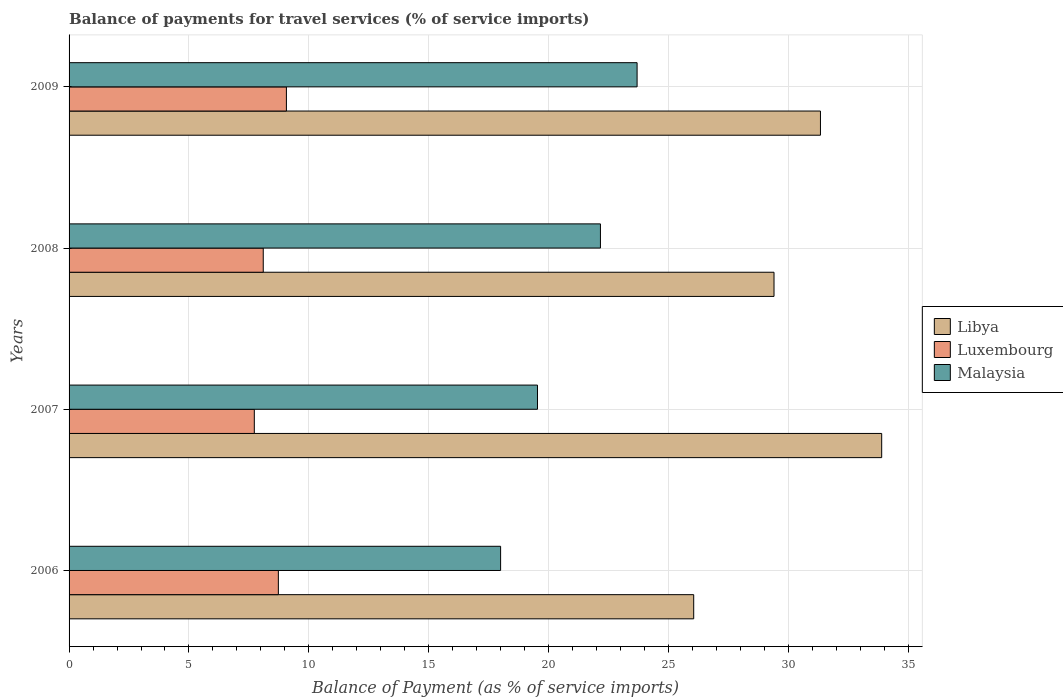How many different coloured bars are there?
Your answer should be compact. 3. How many groups of bars are there?
Your answer should be compact. 4. How many bars are there on the 3rd tick from the bottom?
Provide a short and direct response. 3. In how many cases, is the number of bars for a given year not equal to the number of legend labels?
Make the answer very short. 0. What is the balance of payments for travel services in Malaysia in 2008?
Offer a very short reply. 22.16. Across all years, what is the maximum balance of payments for travel services in Libya?
Your answer should be compact. 33.89. Across all years, what is the minimum balance of payments for travel services in Libya?
Offer a terse response. 26.05. In which year was the balance of payments for travel services in Malaysia minimum?
Provide a succinct answer. 2006. What is the total balance of payments for travel services in Luxembourg in the graph?
Provide a succinct answer. 33.62. What is the difference between the balance of payments for travel services in Libya in 2007 and that in 2008?
Provide a succinct answer. 4.49. What is the difference between the balance of payments for travel services in Luxembourg in 2006 and the balance of payments for travel services in Libya in 2007?
Provide a succinct answer. -25.16. What is the average balance of payments for travel services in Luxembourg per year?
Ensure brevity in your answer.  8.4. In the year 2006, what is the difference between the balance of payments for travel services in Libya and balance of payments for travel services in Luxembourg?
Ensure brevity in your answer.  17.32. In how many years, is the balance of payments for travel services in Libya greater than 14 %?
Your answer should be compact. 4. What is the ratio of the balance of payments for travel services in Malaysia in 2006 to that in 2007?
Ensure brevity in your answer.  0.92. Is the balance of payments for travel services in Luxembourg in 2007 less than that in 2009?
Make the answer very short. Yes. Is the difference between the balance of payments for travel services in Libya in 2006 and 2007 greater than the difference between the balance of payments for travel services in Luxembourg in 2006 and 2007?
Make the answer very short. No. What is the difference between the highest and the second highest balance of payments for travel services in Malaysia?
Your response must be concise. 1.53. What is the difference between the highest and the lowest balance of payments for travel services in Luxembourg?
Make the answer very short. 1.34. In how many years, is the balance of payments for travel services in Libya greater than the average balance of payments for travel services in Libya taken over all years?
Provide a short and direct response. 2. What does the 3rd bar from the top in 2006 represents?
Keep it short and to the point. Libya. What does the 1st bar from the bottom in 2008 represents?
Give a very brief answer. Libya. How many years are there in the graph?
Provide a short and direct response. 4. What is the difference between two consecutive major ticks on the X-axis?
Keep it short and to the point. 5. Does the graph contain any zero values?
Make the answer very short. No. Does the graph contain grids?
Offer a terse response. Yes. Where does the legend appear in the graph?
Offer a terse response. Center right. How many legend labels are there?
Keep it short and to the point. 3. How are the legend labels stacked?
Your answer should be very brief. Vertical. What is the title of the graph?
Offer a very short reply. Balance of payments for travel services (% of service imports). Does "World" appear as one of the legend labels in the graph?
Keep it short and to the point. No. What is the label or title of the X-axis?
Give a very brief answer. Balance of Payment (as % of service imports). What is the label or title of the Y-axis?
Provide a short and direct response. Years. What is the Balance of Payment (as % of service imports) in Libya in 2006?
Your response must be concise. 26.05. What is the Balance of Payment (as % of service imports) in Luxembourg in 2006?
Provide a short and direct response. 8.73. What is the Balance of Payment (as % of service imports) of Malaysia in 2006?
Ensure brevity in your answer.  18. What is the Balance of Payment (as % of service imports) of Libya in 2007?
Ensure brevity in your answer.  33.89. What is the Balance of Payment (as % of service imports) in Luxembourg in 2007?
Provide a short and direct response. 7.73. What is the Balance of Payment (as % of service imports) in Malaysia in 2007?
Keep it short and to the point. 19.54. What is the Balance of Payment (as % of service imports) of Libya in 2008?
Ensure brevity in your answer.  29.4. What is the Balance of Payment (as % of service imports) of Luxembourg in 2008?
Keep it short and to the point. 8.1. What is the Balance of Payment (as % of service imports) in Malaysia in 2008?
Provide a succinct answer. 22.16. What is the Balance of Payment (as % of service imports) in Libya in 2009?
Give a very brief answer. 31.34. What is the Balance of Payment (as % of service imports) of Luxembourg in 2009?
Give a very brief answer. 9.06. What is the Balance of Payment (as % of service imports) in Malaysia in 2009?
Provide a succinct answer. 23.69. Across all years, what is the maximum Balance of Payment (as % of service imports) of Libya?
Keep it short and to the point. 33.89. Across all years, what is the maximum Balance of Payment (as % of service imports) of Luxembourg?
Provide a short and direct response. 9.06. Across all years, what is the maximum Balance of Payment (as % of service imports) of Malaysia?
Provide a short and direct response. 23.69. Across all years, what is the minimum Balance of Payment (as % of service imports) in Libya?
Ensure brevity in your answer.  26.05. Across all years, what is the minimum Balance of Payment (as % of service imports) of Luxembourg?
Ensure brevity in your answer.  7.73. Across all years, what is the minimum Balance of Payment (as % of service imports) in Malaysia?
Provide a succinct answer. 18. What is the total Balance of Payment (as % of service imports) in Libya in the graph?
Offer a very short reply. 120.69. What is the total Balance of Payment (as % of service imports) of Luxembourg in the graph?
Provide a short and direct response. 33.62. What is the total Balance of Payment (as % of service imports) of Malaysia in the graph?
Your answer should be compact. 83.39. What is the difference between the Balance of Payment (as % of service imports) of Libya in 2006 and that in 2007?
Make the answer very short. -7.84. What is the difference between the Balance of Payment (as % of service imports) in Luxembourg in 2006 and that in 2007?
Offer a terse response. 1. What is the difference between the Balance of Payment (as % of service imports) in Malaysia in 2006 and that in 2007?
Offer a terse response. -1.54. What is the difference between the Balance of Payment (as % of service imports) of Libya in 2006 and that in 2008?
Your response must be concise. -3.35. What is the difference between the Balance of Payment (as % of service imports) in Luxembourg in 2006 and that in 2008?
Keep it short and to the point. 0.63. What is the difference between the Balance of Payment (as % of service imports) in Malaysia in 2006 and that in 2008?
Your answer should be compact. -4.16. What is the difference between the Balance of Payment (as % of service imports) in Libya in 2006 and that in 2009?
Provide a short and direct response. -5.29. What is the difference between the Balance of Payment (as % of service imports) of Luxembourg in 2006 and that in 2009?
Provide a short and direct response. -0.34. What is the difference between the Balance of Payment (as % of service imports) of Malaysia in 2006 and that in 2009?
Provide a short and direct response. -5.69. What is the difference between the Balance of Payment (as % of service imports) in Libya in 2007 and that in 2008?
Ensure brevity in your answer.  4.49. What is the difference between the Balance of Payment (as % of service imports) in Luxembourg in 2007 and that in 2008?
Provide a succinct answer. -0.37. What is the difference between the Balance of Payment (as % of service imports) of Malaysia in 2007 and that in 2008?
Your response must be concise. -2.63. What is the difference between the Balance of Payment (as % of service imports) in Libya in 2007 and that in 2009?
Your answer should be very brief. 2.55. What is the difference between the Balance of Payment (as % of service imports) of Luxembourg in 2007 and that in 2009?
Keep it short and to the point. -1.34. What is the difference between the Balance of Payment (as % of service imports) in Malaysia in 2007 and that in 2009?
Provide a succinct answer. -4.15. What is the difference between the Balance of Payment (as % of service imports) of Libya in 2008 and that in 2009?
Give a very brief answer. -1.94. What is the difference between the Balance of Payment (as % of service imports) in Luxembourg in 2008 and that in 2009?
Your answer should be very brief. -0.97. What is the difference between the Balance of Payment (as % of service imports) of Malaysia in 2008 and that in 2009?
Give a very brief answer. -1.53. What is the difference between the Balance of Payment (as % of service imports) in Libya in 2006 and the Balance of Payment (as % of service imports) in Luxembourg in 2007?
Offer a very short reply. 18.33. What is the difference between the Balance of Payment (as % of service imports) of Libya in 2006 and the Balance of Payment (as % of service imports) of Malaysia in 2007?
Offer a terse response. 6.52. What is the difference between the Balance of Payment (as % of service imports) in Luxembourg in 2006 and the Balance of Payment (as % of service imports) in Malaysia in 2007?
Your response must be concise. -10.81. What is the difference between the Balance of Payment (as % of service imports) of Libya in 2006 and the Balance of Payment (as % of service imports) of Luxembourg in 2008?
Give a very brief answer. 17.95. What is the difference between the Balance of Payment (as % of service imports) in Libya in 2006 and the Balance of Payment (as % of service imports) in Malaysia in 2008?
Make the answer very short. 3.89. What is the difference between the Balance of Payment (as % of service imports) of Luxembourg in 2006 and the Balance of Payment (as % of service imports) of Malaysia in 2008?
Your answer should be compact. -13.43. What is the difference between the Balance of Payment (as % of service imports) of Libya in 2006 and the Balance of Payment (as % of service imports) of Luxembourg in 2009?
Offer a very short reply. 16.99. What is the difference between the Balance of Payment (as % of service imports) of Libya in 2006 and the Balance of Payment (as % of service imports) of Malaysia in 2009?
Provide a short and direct response. 2.36. What is the difference between the Balance of Payment (as % of service imports) of Luxembourg in 2006 and the Balance of Payment (as % of service imports) of Malaysia in 2009?
Provide a short and direct response. -14.96. What is the difference between the Balance of Payment (as % of service imports) of Libya in 2007 and the Balance of Payment (as % of service imports) of Luxembourg in 2008?
Your response must be concise. 25.79. What is the difference between the Balance of Payment (as % of service imports) in Libya in 2007 and the Balance of Payment (as % of service imports) in Malaysia in 2008?
Make the answer very short. 11.73. What is the difference between the Balance of Payment (as % of service imports) of Luxembourg in 2007 and the Balance of Payment (as % of service imports) of Malaysia in 2008?
Provide a short and direct response. -14.44. What is the difference between the Balance of Payment (as % of service imports) in Libya in 2007 and the Balance of Payment (as % of service imports) in Luxembourg in 2009?
Offer a terse response. 24.83. What is the difference between the Balance of Payment (as % of service imports) in Libya in 2007 and the Balance of Payment (as % of service imports) in Malaysia in 2009?
Your answer should be compact. 10.2. What is the difference between the Balance of Payment (as % of service imports) of Luxembourg in 2007 and the Balance of Payment (as % of service imports) of Malaysia in 2009?
Provide a short and direct response. -15.97. What is the difference between the Balance of Payment (as % of service imports) in Libya in 2008 and the Balance of Payment (as % of service imports) in Luxembourg in 2009?
Your response must be concise. 20.34. What is the difference between the Balance of Payment (as % of service imports) of Libya in 2008 and the Balance of Payment (as % of service imports) of Malaysia in 2009?
Your answer should be compact. 5.71. What is the difference between the Balance of Payment (as % of service imports) in Luxembourg in 2008 and the Balance of Payment (as % of service imports) in Malaysia in 2009?
Your answer should be compact. -15.59. What is the average Balance of Payment (as % of service imports) of Libya per year?
Keep it short and to the point. 30.17. What is the average Balance of Payment (as % of service imports) in Luxembourg per year?
Make the answer very short. 8.4. What is the average Balance of Payment (as % of service imports) of Malaysia per year?
Your answer should be compact. 20.85. In the year 2006, what is the difference between the Balance of Payment (as % of service imports) of Libya and Balance of Payment (as % of service imports) of Luxembourg?
Give a very brief answer. 17.32. In the year 2006, what is the difference between the Balance of Payment (as % of service imports) of Libya and Balance of Payment (as % of service imports) of Malaysia?
Your answer should be compact. 8.05. In the year 2006, what is the difference between the Balance of Payment (as % of service imports) of Luxembourg and Balance of Payment (as % of service imports) of Malaysia?
Offer a terse response. -9.27. In the year 2007, what is the difference between the Balance of Payment (as % of service imports) of Libya and Balance of Payment (as % of service imports) of Luxembourg?
Offer a very short reply. 26.17. In the year 2007, what is the difference between the Balance of Payment (as % of service imports) in Libya and Balance of Payment (as % of service imports) in Malaysia?
Give a very brief answer. 14.36. In the year 2007, what is the difference between the Balance of Payment (as % of service imports) of Luxembourg and Balance of Payment (as % of service imports) of Malaysia?
Your answer should be compact. -11.81. In the year 2008, what is the difference between the Balance of Payment (as % of service imports) in Libya and Balance of Payment (as % of service imports) in Luxembourg?
Offer a very short reply. 21.3. In the year 2008, what is the difference between the Balance of Payment (as % of service imports) in Libya and Balance of Payment (as % of service imports) in Malaysia?
Your answer should be very brief. 7.24. In the year 2008, what is the difference between the Balance of Payment (as % of service imports) in Luxembourg and Balance of Payment (as % of service imports) in Malaysia?
Offer a terse response. -14.06. In the year 2009, what is the difference between the Balance of Payment (as % of service imports) of Libya and Balance of Payment (as % of service imports) of Luxembourg?
Provide a short and direct response. 22.27. In the year 2009, what is the difference between the Balance of Payment (as % of service imports) of Libya and Balance of Payment (as % of service imports) of Malaysia?
Offer a terse response. 7.65. In the year 2009, what is the difference between the Balance of Payment (as % of service imports) in Luxembourg and Balance of Payment (as % of service imports) in Malaysia?
Offer a very short reply. -14.63. What is the ratio of the Balance of Payment (as % of service imports) in Libya in 2006 to that in 2007?
Offer a terse response. 0.77. What is the ratio of the Balance of Payment (as % of service imports) in Luxembourg in 2006 to that in 2007?
Provide a succinct answer. 1.13. What is the ratio of the Balance of Payment (as % of service imports) in Malaysia in 2006 to that in 2007?
Keep it short and to the point. 0.92. What is the ratio of the Balance of Payment (as % of service imports) of Libya in 2006 to that in 2008?
Make the answer very short. 0.89. What is the ratio of the Balance of Payment (as % of service imports) in Luxembourg in 2006 to that in 2008?
Make the answer very short. 1.08. What is the ratio of the Balance of Payment (as % of service imports) in Malaysia in 2006 to that in 2008?
Your response must be concise. 0.81. What is the ratio of the Balance of Payment (as % of service imports) of Libya in 2006 to that in 2009?
Your answer should be very brief. 0.83. What is the ratio of the Balance of Payment (as % of service imports) of Luxembourg in 2006 to that in 2009?
Your answer should be compact. 0.96. What is the ratio of the Balance of Payment (as % of service imports) of Malaysia in 2006 to that in 2009?
Offer a very short reply. 0.76. What is the ratio of the Balance of Payment (as % of service imports) of Libya in 2007 to that in 2008?
Your answer should be very brief. 1.15. What is the ratio of the Balance of Payment (as % of service imports) of Luxembourg in 2007 to that in 2008?
Ensure brevity in your answer.  0.95. What is the ratio of the Balance of Payment (as % of service imports) of Malaysia in 2007 to that in 2008?
Make the answer very short. 0.88. What is the ratio of the Balance of Payment (as % of service imports) in Libya in 2007 to that in 2009?
Your answer should be compact. 1.08. What is the ratio of the Balance of Payment (as % of service imports) in Luxembourg in 2007 to that in 2009?
Give a very brief answer. 0.85. What is the ratio of the Balance of Payment (as % of service imports) of Malaysia in 2007 to that in 2009?
Your answer should be compact. 0.82. What is the ratio of the Balance of Payment (as % of service imports) of Libya in 2008 to that in 2009?
Your answer should be compact. 0.94. What is the ratio of the Balance of Payment (as % of service imports) in Luxembourg in 2008 to that in 2009?
Offer a terse response. 0.89. What is the ratio of the Balance of Payment (as % of service imports) in Malaysia in 2008 to that in 2009?
Provide a short and direct response. 0.94. What is the difference between the highest and the second highest Balance of Payment (as % of service imports) in Libya?
Your answer should be compact. 2.55. What is the difference between the highest and the second highest Balance of Payment (as % of service imports) of Luxembourg?
Keep it short and to the point. 0.34. What is the difference between the highest and the second highest Balance of Payment (as % of service imports) in Malaysia?
Keep it short and to the point. 1.53. What is the difference between the highest and the lowest Balance of Payment (as % of service imports) of Libya?
Give a very brief answer. 7.84. What is the difference between the highest and the lowest Balance of Payment (as % of service imports) of Luxembourg?
Keep it short and to the point. 1.34. What is the difference between the highest and the lowest Balance of Payment (as % of service imports) in Malaysia?
Offer a very short reply. 5.69. 